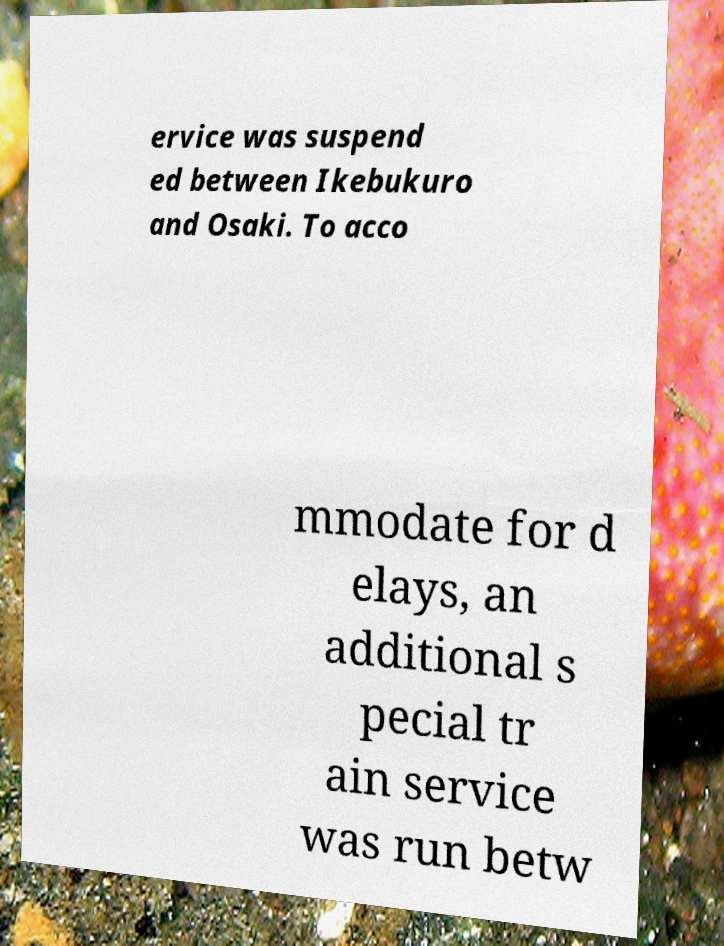Can you accurately transcribe the text from the provided image for me? ervice was suspend ed between Ikebukuro and Osaki. To acco mmodate for d elays, an additional s pecial tr ain service was run betw 